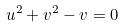<formula> <loc_0><loc_0><loc_500><loc_500>u ^ { 2 } + v ^ { 2 } - v = 0</formula> 